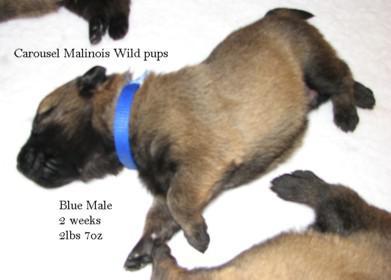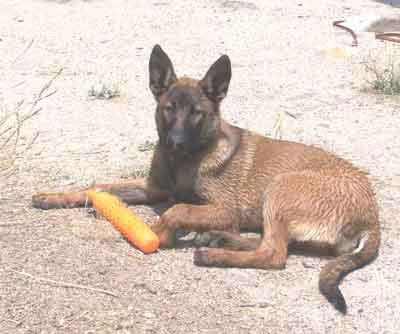The first image is the image on the left, the second image is the image on the right. Considering the images on both sides, is "An image shows one standing german shepherd facing leftward." valid? Answer yes or no. No. 